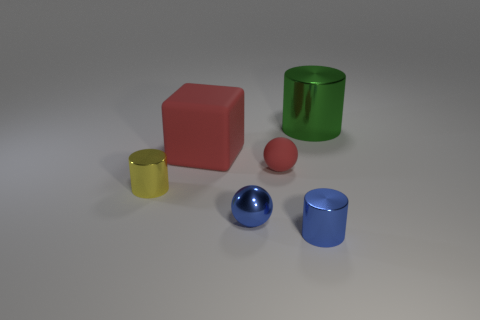Subtract all green shiny cylinders. How many cylinders are left? 2 Add 1 yellow metal cylinders. How many objects exist? 7 Subtract all green cylinders. How many cylinders are left? 2 Subtract all blocks. How many objects are left? 5 Subtract 2 cylinders. How many cylinders are left? 1 Subtract all cyan balls. Subtract all brown cylinders. How many balls are left? 2 Subtract all blue shiny balls. Subtract all blue things. How many objects are left? 3 Add 6 metallic objects. How many metallic objects are left? 10 Add 6 tiny blue metallic balls. How many tiny blue metallic balls exist? 7 Subtract 0 purple balls. How many objects are left? 6 